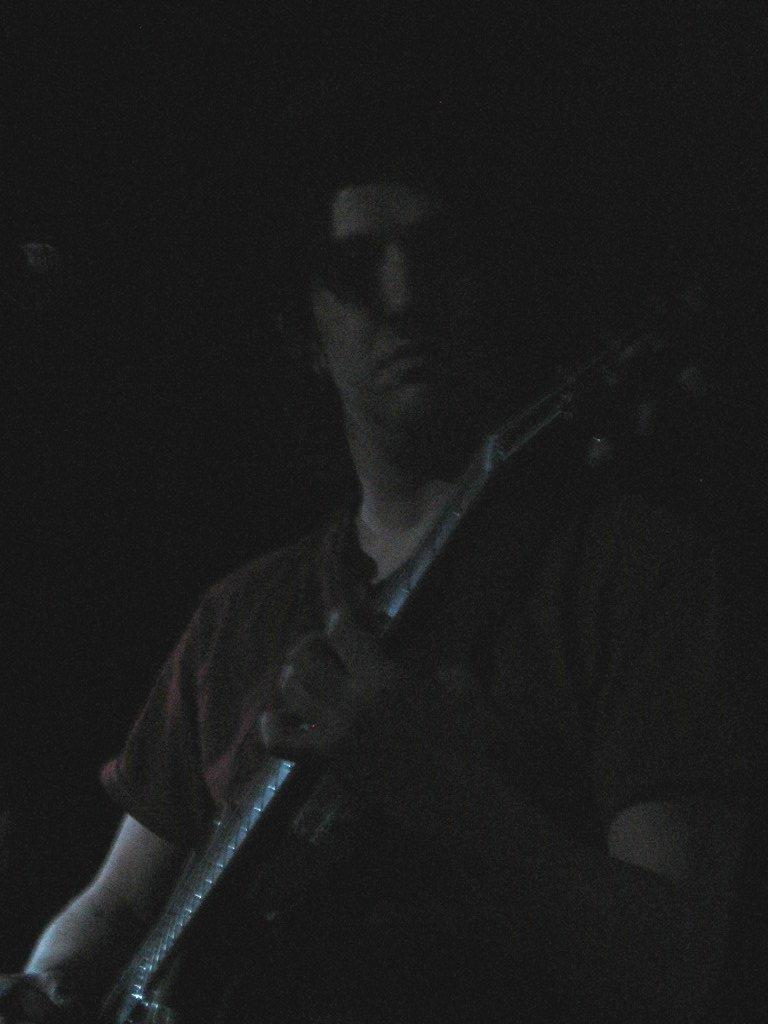Who is the main subject in the image? There is a man in the image. Where is the man positioned in the image? The man is standing in the middle of the image. What is the man holding in the image? The man is holding a guitar. What type of dog is visible in the image? There is no dog present in the image. How does the man's body language convey his afterthoughts in the image? The image does not show the man's body language or any afterthoughts, as it only depicts him standing and holding a guitar. 